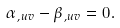<formula> <loc_0><loc_0><loc_500><loc_500>\alpha _ { , u v } - \beta _ { , u v } = 0 .</formula> 